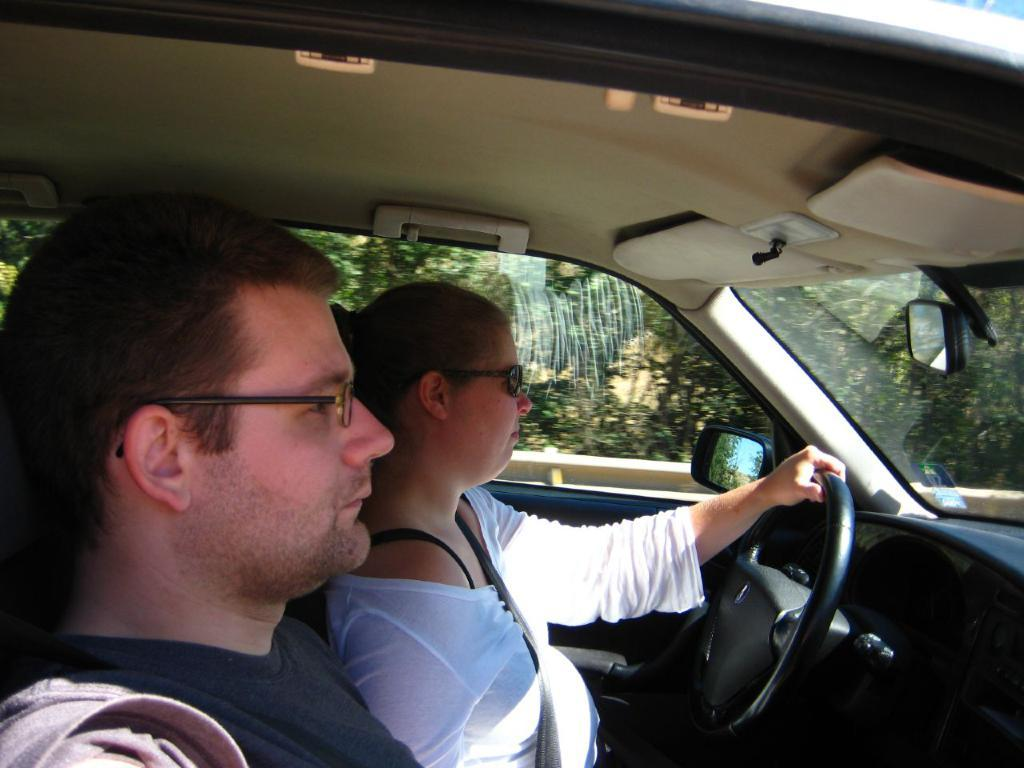Who is present in the image? There is a woman and a man in the image. What is the woman wearing? The woman is wearing goggles. What is the woman holding? The woman is holding a steering wheel. Where are the woman and man located? Both the woman and man are inside a car. What can be seen through the car window? Trees are visible through the car window. What type of chalk is the woman using to draw on the car window? There is no chalk present in the image, and the woman is not drawing on the car window. How many bikes are parked next to the car in the image? There are no bikes present in the image. 